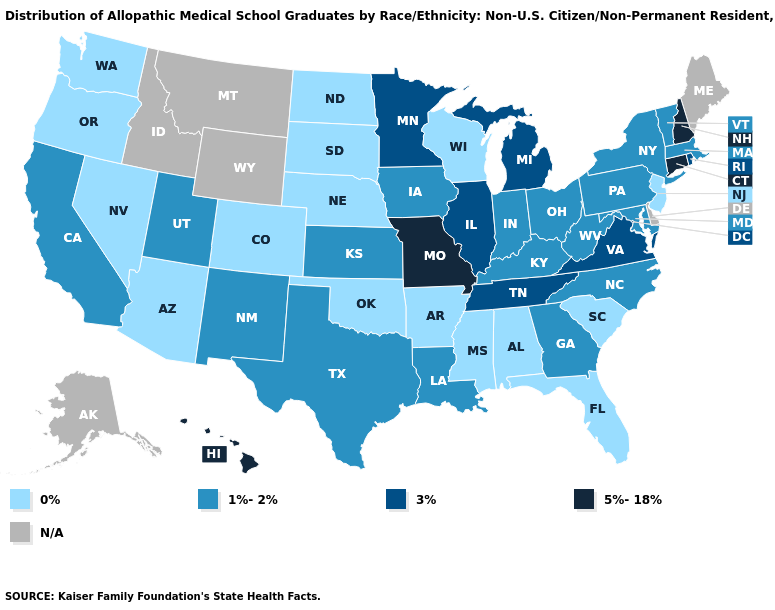Name the states that have a value in the range 0%?
Keep it brief. Alabama, Arizona, Arkansas, Colorado, Florida, Mississippi, Nebraska, Nevada, New Jersey, North Dakota, Oklahoma, Oregon, South Carolina, South Dakota, Washington, Wisconsin. How many symbols are there in the legend?
Answer briefly. 5. Which states hav the highest value in the South?
Give a very brief answer. Tennessee, Virginia. Name the states that have a value in the range N/A?
Be succinct. Alaska, Delaware, Idaho, Maine, Montana, Wyoming. How many symbols are there in the legend?
Keep it brief. 5. What is the highest value in the West ?
Short answer required. 5%-18%. Does Hawaii have the highest value in the West?
Keep it brief. Yes. Does Illinois have the highest value in the MidWest?
Give a very brief answer. No. Does Kansas have the lowest value in the MidWest?
Write a very short answer. No. What is the value of Florida?
Keep it brief. 0%. What is the value of Colorado?
Give a very brief answer. 0%. What is the value of Nevada?
Quick response, please. 0%. Does Arkansas have the lowest value in the USA?
Concise answer only. Yes. Does Wisconsin have the lowest value in the MidWest?
Be succinct. Yes. 